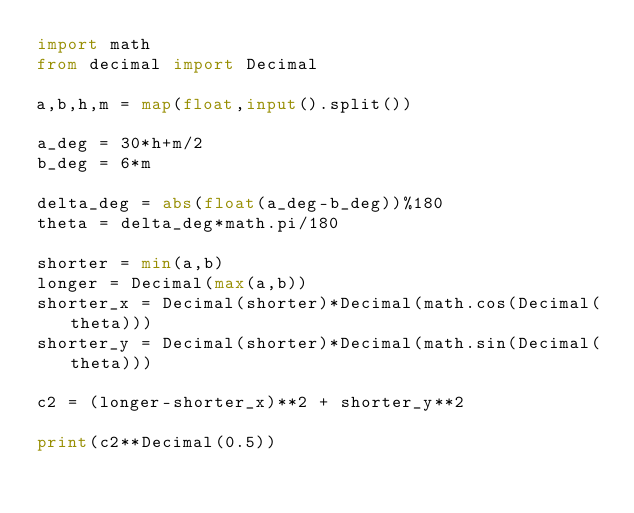<code> <loc_0><loc_0><loc_500><loc_500><_Python_>import math
from decimal import Decimal

a,b,h,m = map(float,input().split())

a_deg = 30*h+m/2
b_deg = 6*m

delta_deg = abs(float(a_deg-b_deg))%180
theta = delta_deg*math.pi/180

shorter = min(a,b)
longer = Decimal(max(a,b))
shorter_x = Decimal(shorter)*Decimal(math.cos(Decimal(theta)))
shorter_y = Decimal(shorter)*Decimal(math.sin(Decimal(theta)))

c2 = (longer-shorter_x)**2 + shorter_y**2

print(c2**Decimal(0.5))</code> 